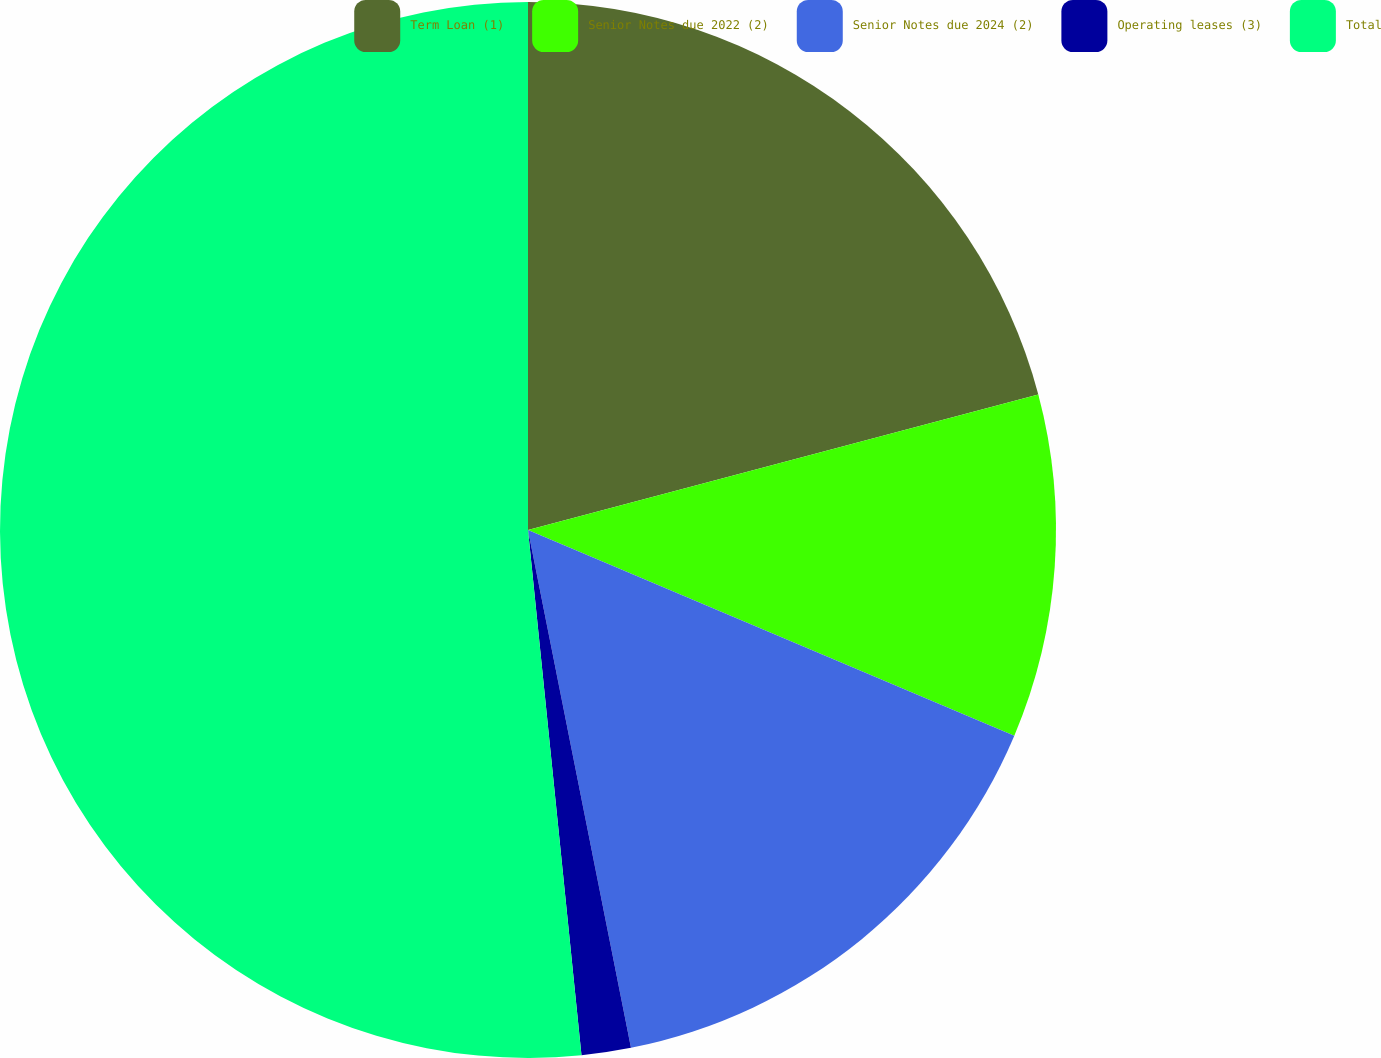<chart> <loc_0><loc_0><loc_500><loc_500><pie_chart><fcel>Term Loan (1)<fcel>Senior Notes due 2022 (2)<fcel>Senior Notes due 2024 (2)<fcel>Operating leases (3)<fcel>Total<nl><fcel>20.87%<fcel>10.5%<fcel>15.51%<fcel>1.51%<fcel>51.62%<nl></chart> 